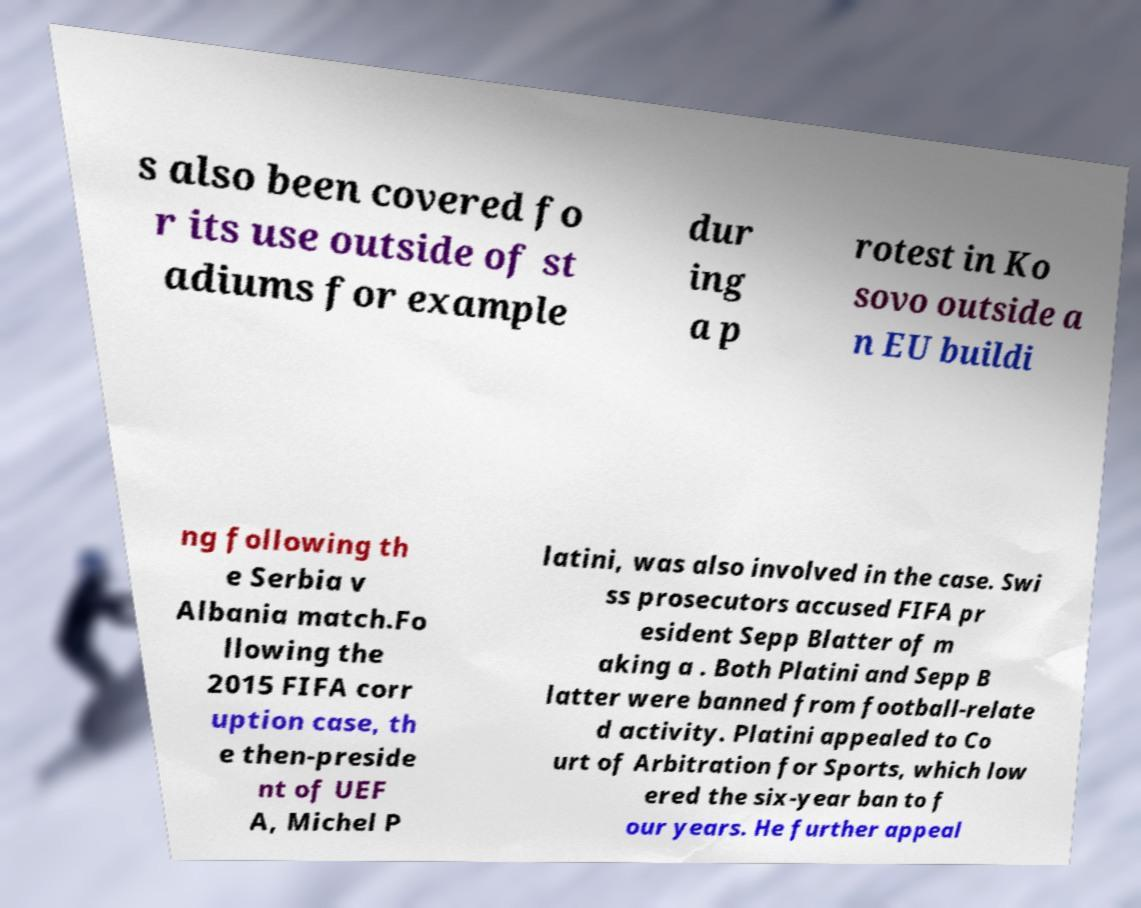I need the written content from this picture converted into text. Can you do that? s also been covered fo r its use outside of st adiums for example dur ing a p rotest in Ko sovo outside a n EU buildi ng following th e Serbia v Albania match.Fo llowing the 2015 FIFA corr uption case, th e then-preside nt of UEF A, Michel P latini, was also involved in the case. Swi ss prosecutors accused FIFA pr esident Sepp Blatter of m aking a . Both Platini and Sepp B latter were banned from football-relate d activity. Platini appealed to Co urt of Arbitration for Sports, which low ered the six-year ban to f our years. He further appeal 